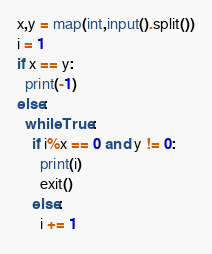Convert code to text. <code><loc_0><loc_0><loc_500><loc_500><_Python_>x,y = map(int,input().split())
i = 1
if x == y:
  print(-1)
else:
  while True:
    if i%x == 0 and y != 0:
      print(i)
      exit()
    else:
      i += 1</code> 